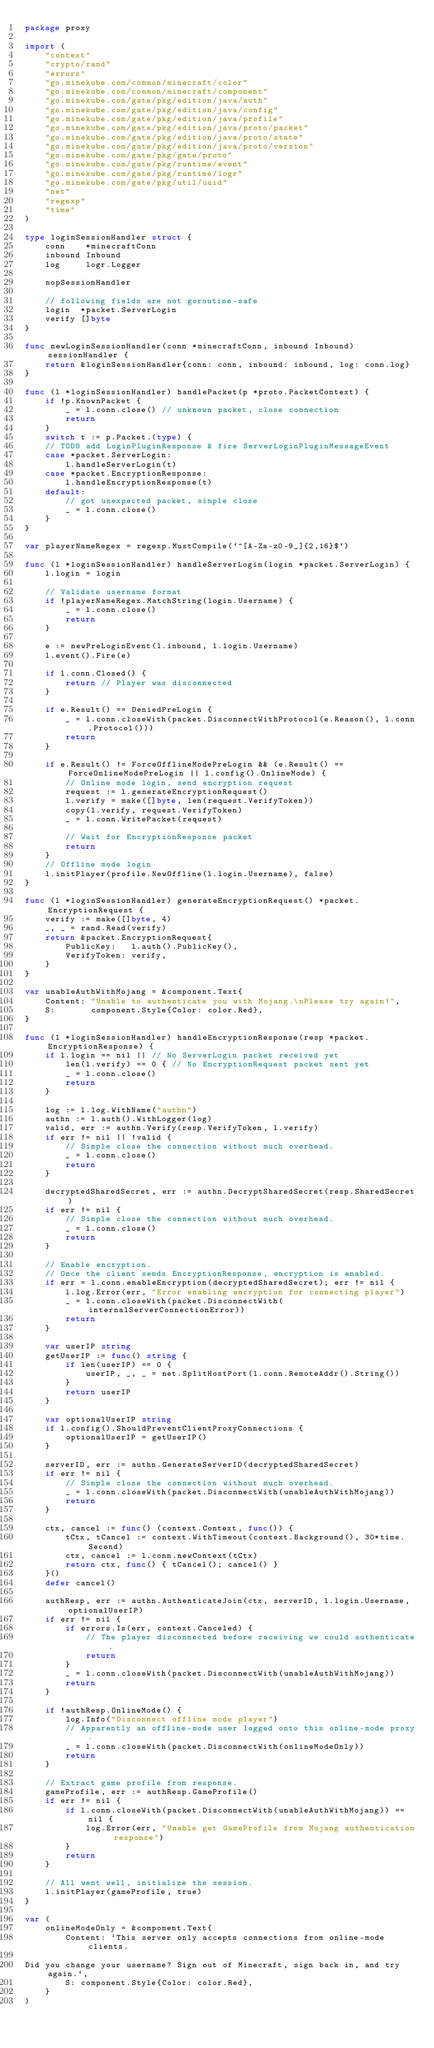Convert code to text. <code><loc_0><loc_0><loc_500><loc_500><_Go_>package proxy

import (
	"context"
	"crypto/rand"
	"errors"
	"go.minekube.com/common/minecraft/color"
	"go.minekube.com/common/minecraft/component"
	"go.minekube.com/gate/pkg/edition/java/auth"
	"go.minekube.com/gate/pkg/edition/java/config"
	"go.minekube.com/gate/pkg/edition/java/profile"
	"go.minekube.com/gate/pkg/edition/java/proto/packet"
	"go.minekube.com/gate/pkg/edition/java/proto/state"
	"go.minekube.com/gate/pkg/edition/java/proto/version"
	"go.minekube.com/gate/pkg/gate/proto"
	"go.minekube.com/gate/pkg/runtime/event"
	"go.minekube.com/gate/pkg/runtime/logr"
	"go.minekube.com/gate/pkg/util/uuid"
	"net"
	"regexp"
	"time"
)

type loginSessionHandler struct {
	conn    *minecraftConn
	inbound Inbound
	log     logr.Logger

	nopSessionHandler

	// following fields are not goroutine-safe
	login  *packet.ServerLogin
	verify []byte
}

func newLoginSessionHandler(conn *minecraftConn, inbound Inbound) sessionHandler {
	return &loginSessionHandler{conn: conn, inbound: inbound, log: conn.log}
}

func (l *loginSessionHandler) handlePacket(p *proto.PacketContext) {
	if !p.KnownPacket {
		_ = l.conn.close() // unknown packet, close connection
		return
	}
	switch t := p.Packet.(type) {
	// TODO add LoginPluginResponse & fire ServerLoginPluginMessageEvent
	case *packet.ServerLogin:
		l.handleServerLogin(t)
	case *packet.EncryptionResponse:
		l.handleEncryptionResponse(t)
	default:
		// got unexpected packet, simple close
		_ = l.conn.close()
	}
}

var playerNameRegex = regexp.MustCompile(`^[A-Za-z0-9_]{2,16}$`)

func (l *loginSessionHandler) handleServerLogin(login *packet.ServerLogin) {
	l.login = login

	// Validate username format
	if !playerNameRegex.MatchString(login.Username) {
		_ = l.conn.close()
		return
	}

	e := newPreLoginEvent(l.inbound, l.login.Username)
	l.event().Fire(e)

	if l.conn.Closed() {
		return // Player was disconnected
	}

	if e.Result() == DeniedPreLogin {
		_ = l.conn.closeWith(packet.DisconnectWithProtocol(e.Reason(), l.conn.Protocol()))
		return
	}

	if e.Result() != ForceOfflineModePreLogin && (e.Result() == ForceOnlineModePreLogin || l.config().OnlineMode) {
		// Online mode login, send encryption request
		request := l.generateEncryptionRequest()
		l.verify = make([]byte, len(request.VerifyToken))
		copy(l.verify, request.VerifyToken)
		_ = l.conn.WritePacket(request)

		// Wait for EncryptionResponse packet
		return
	}
	// Offline mode login
	l.initPlayer(profile.NewOffline(l.login.Username), false)
}

func (l *loginSessionHandler) generateEncryptionRequest() *packet.EncryptionRequest {
	verify := make([]byte, 4)
	_, _ = rand.Read(verify)
	return &packet.EncryptionRequest{
		PublicKey:   l.auth().PublicKey(),
		VerifyToken: verify,
	}
}

var unableAuthWithMojang = &component.Text{
	Content: "Unable to authenticate you with Mojang.\nPlease try again!",
	S:       component.Style{Color: color.Red},
}

func (l *loginSessionHandler) handleEncryptionResponse(resp *packet.EncryptionResponse) {
	if l.login == nil || // No ServerLogin packet received yet
		len(l.verify) == 0 { // No EncryptionRequest packet sent yet
		_ = l.conn.close()
		return
	}

	log := l.log.WithName("authn")
	authn := l.auth().WithLogger(log)
	valid, err := authn.Verify(resp.VerifyToken, l.verify)
	if err != nil || !valid {
		// Simple close the connection without much overhead.
		_ = l.conn.close()
		return
	}

	decryptedSharedSecret, err := authn.DecryptSharedSecret(resp.SharedSecret)
	if err != nil {
		// Simple close the connection without much overhead.
		_ = l.conn.close()
		return
	}

	// Enable encryption.
	// Once the client sends EncryptionResponse, encryption is enabled.
	if err = l.conn.enableEncryption(decryptedSharedSecret); err != nil {
		l.log.Error(err, "Error enabling encryption for connecting player")
		_ = l.conn.closeWith(packet.DisconnectWith(internalServerConnectionError))
		return
	}

	var userIP string
	getUserIP := func() string {
		if len(userIP) == 0 {
			userIP, _, _ = net.SplitHostPort(l.conn.RemoteAddr().String())
		}
		return userIP
	}

	var optionalUserIP string
	if l.config().ShouldPreventClientProxyConnections {
		optionalUserIP = getUserIP()
	}

	serverID, err := authn.GenerateServerID(decryptedSharedSecret)
	if err != nil {
		// Simple close the connection without much overhead.
		_ = l.conn.closeWith(packet.DisconnectWith(unableAuthWithMojang))
		return
	}

	ctx, cancel := func() (context.Context, func()) {
		tCtx, tCancel := context.WithTimeout(context.Background(), 30*time.Second)
		ctx, cancel := l.conn.newContext(tCtx)
		return ctx, func() { tCancel(); cancel() }
	}()
	defer cancel()

	authResp, err := authn.AuthenticateJoin(ctx, serverID, l.login.Username, optionalUserIP)
	if err != nil {
		if errors.Is(err, context.Canceled) {
			// The player disconnected before receiving we could authenticate.
			return
		}
		_ = l.conn.closeWith(packet.DisconnectWith(unableAuthWithMojang))
		return
	}

	if !authResp.OnlineMode() {
		log.Info("Disconnect offline mode player")
		// Apparently an offline-mode user logged onto this online-mode proxy.
		_ = l.conn.closeWith(packet.DisconnectWith(onlineModeOnly))
		return
	}

	// Extract game profile from response.
	gameProfile, err := authResp.GameProfile()
	if err != nil {
		if l.conn.closeWith(packet.DisconnectWith(unableAuthWithMojang)) == nil {
			log.Error(err, "Unable get GameProfile from Mojang authentication response")
		}
		return
	}

	// All went well, initialize the session.
	l.initPlayer(gameProfile, true)
}

var (
	onlineModeOnly = &component.Text{
		Content: `This server only accepts connections from online-mode clients.

Did you change your username? Sign out of Minecraft, sign back in, and try again.`,
		S: component.Style{Color: color.Red},
	}
)
</code> 